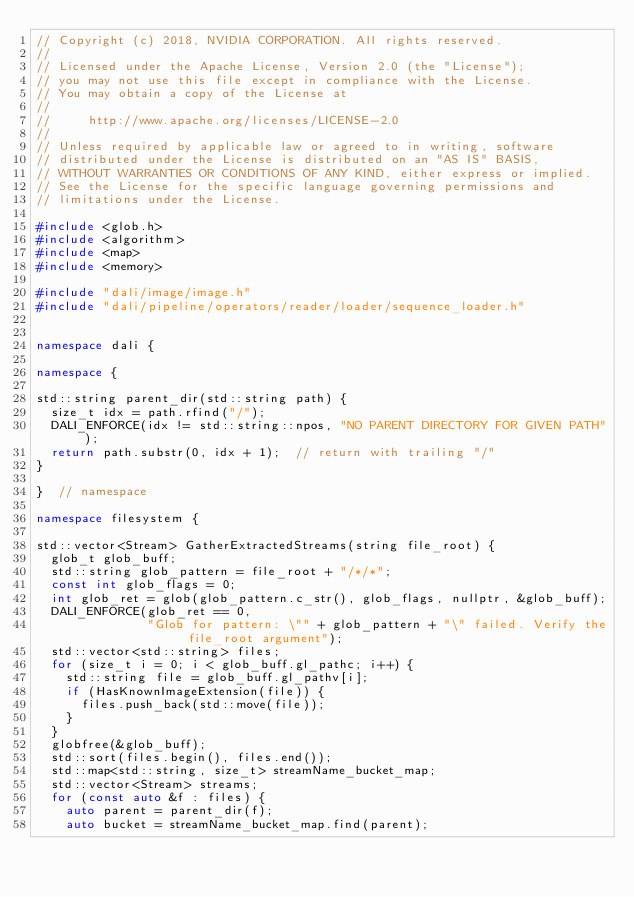<code> <loc_0><loc_0><loc_500><loc_500><_C++_>// Copyright (c) 2018, NVIDIA CORPORATION. All rights reserved.
//
// Licensed under the Apache License, Version 2.0 (the "License");
// you may not use this file except in compliance with the License.
// You may obtain a copy of the License at
//
//     http://www.apache.org/licenses/LICENSE-2.0
//
// Unless required by applicable law or agreed to in writing, software
// distributed under the License is distributed on an "AS IS" BASIS,
// WITHOUT WARRANTIES OR CONDITIONS OF ANY KIND, either express or implied.
// See the License for the specific language governing permissions and
// limitations under the License.

#include <glob.h>
#include <algorithm>
#include <map>
#include <memory>

#include "dali/image/image.h"
#include "dali/pipeline/operators/reader/loader/sequence_loader.h"


namespace dali {

namespace {

std::string parent_dir(std::string path) {
  size_t idx = path.rfind("/");
  DALI_ENFORCE(idx != std::string::npos, "NO PARENT DIRECTORY FOR GIVEN PATH");
  return path.substr(0, idx + 1);  // return with trailing "/"
}

}  // namespace

namespace filesystem {

std::vector<Stream> GatherExtractedStreams(string file_root) {
  glob_t glob_buff;
  std::string glob_pattern = file_root + "/*/*";
  const int glob_flags = 0;
  int glob_ret = glob(glob_pattern.c_str(), glob_flags, nullptr, &glob_buff);
  DALI_ENFORCE(glob_ret == 0,
               "Glob for pattern: \"" + glob_pattern + "\" failed. Verify the file_root argument");
  std::vector<std::string> files;
  for (size_t i = 0; i < glob_buff.gl_pathc; i++) {
    std::string file = glob_buff.gl_pathv[i];
    if (HasKnownImageExtension(file)) {
      files.push_back(std::move(file));
    }
  }
  globfree(&glob_buff);
  std::sort(files.begin(), files.end());
  std::map<std::string, size_t> streamName_bucket_map;
  std::vector<Stream> streams;
  for (const auto &f : files) {
    auto parent = parent_dir(f);
    auto bucket = streamName_bucket_map.find(parent);</code> 